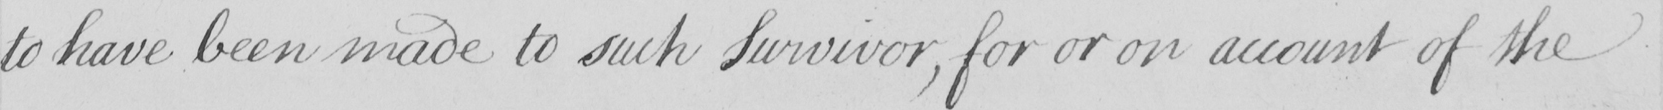Please provide the text content of this handwritten line. to have been made to such Survivor , for or on account of the 